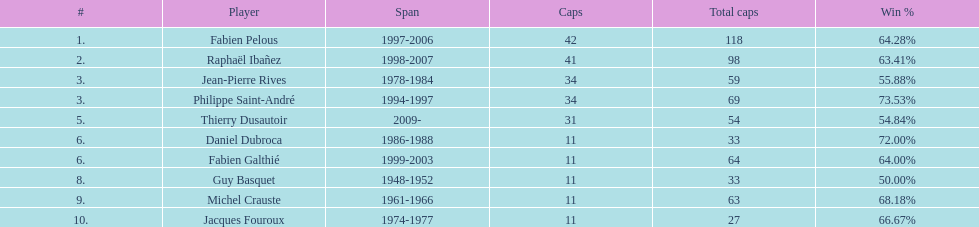Which captain served for the least duration? Daniel Dubroca. 